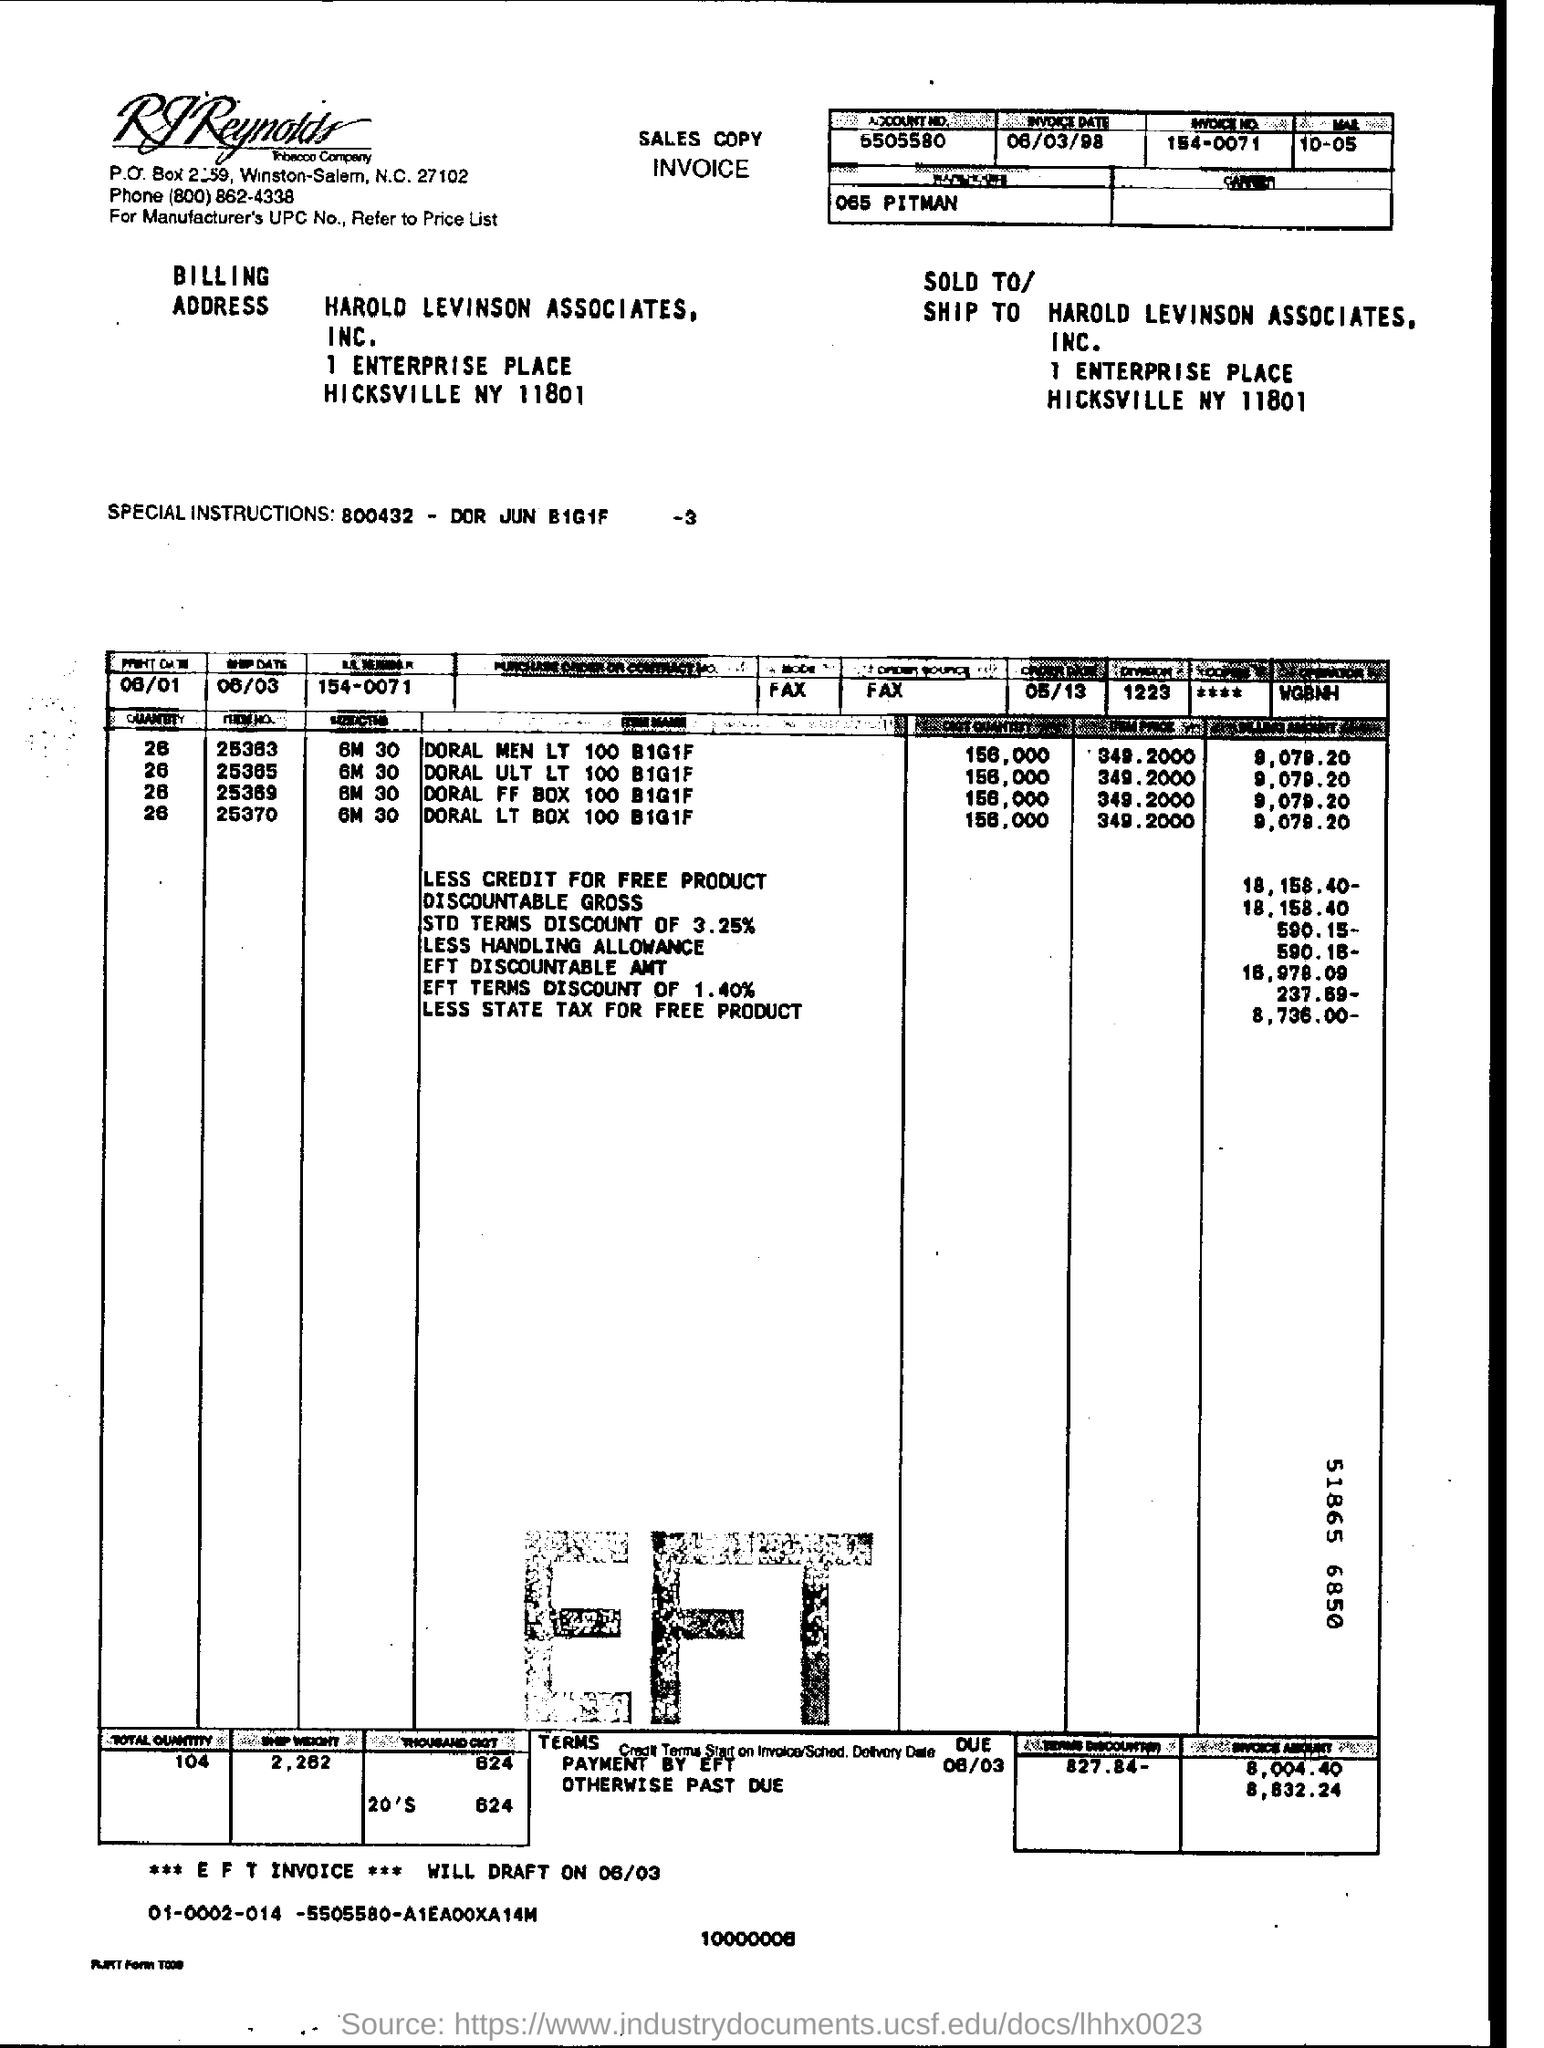I see terms '2% 10 NET 30'. What does that mean? This notation means that the payer can take a 2% discount if they pay the invoice within 10 days. Otherwise, the full net amount is due within 30 days of the invoice date. 